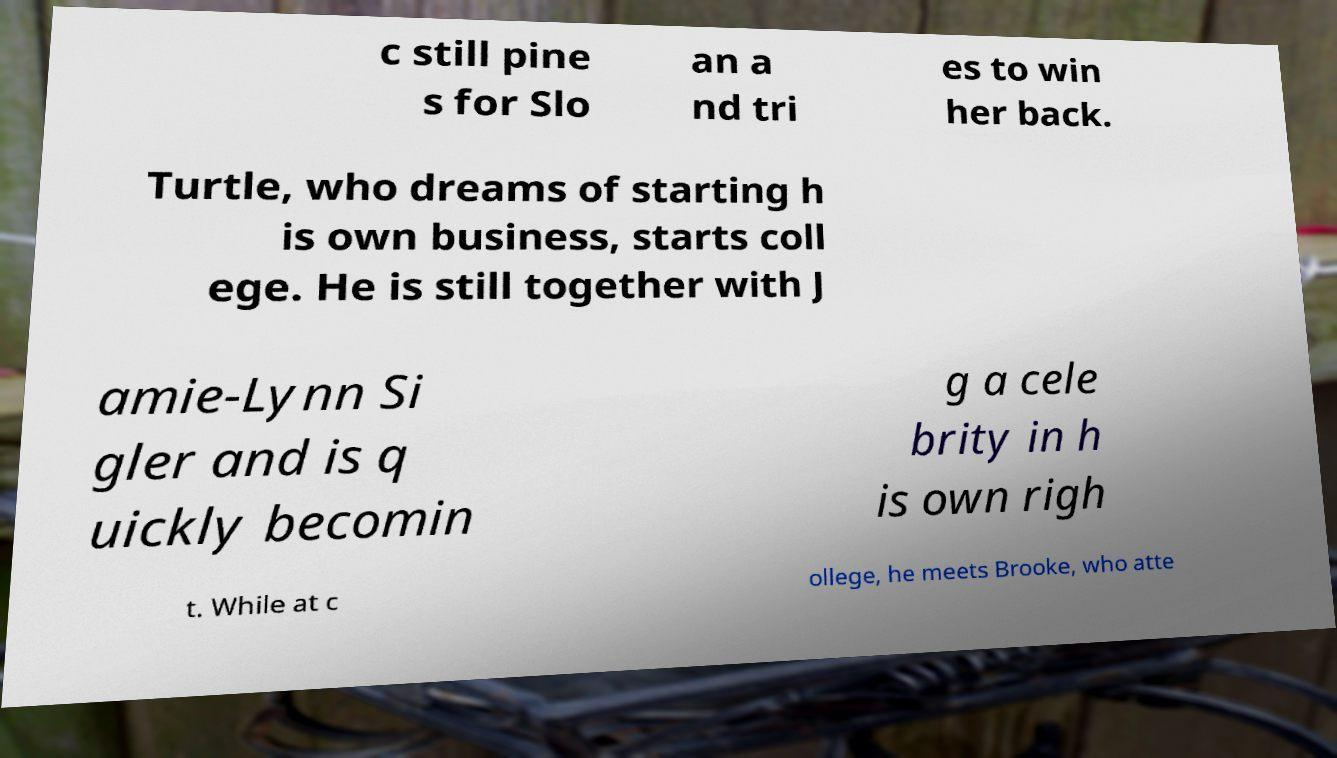Please identify and transcribe the text found in this image. c still pine s for Slo an a nd tri es to win her back. Turtle, who dreams of starting h is own business, starts coll ege. He is still together with J amie-Lynn Si gler and is q uickly becomin g a cele brity in h is own righ t. While at c ollege, he meets Brooke, who atte 